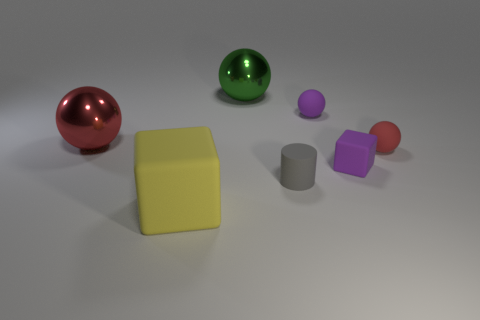Add 1 yellow metallic things. How many objects exist? 8 Subtract all balls. How many objects are left? 3 Subtract 0 yellow balls. How many objects are left? 7 Subtract all tiny gray cubes. Subtract all small red spheres. How many objects are left? 6 Add 7 purple blocks. How many purple blocks are left? 8 Add 6 purple things. How many purple things exist? 8 